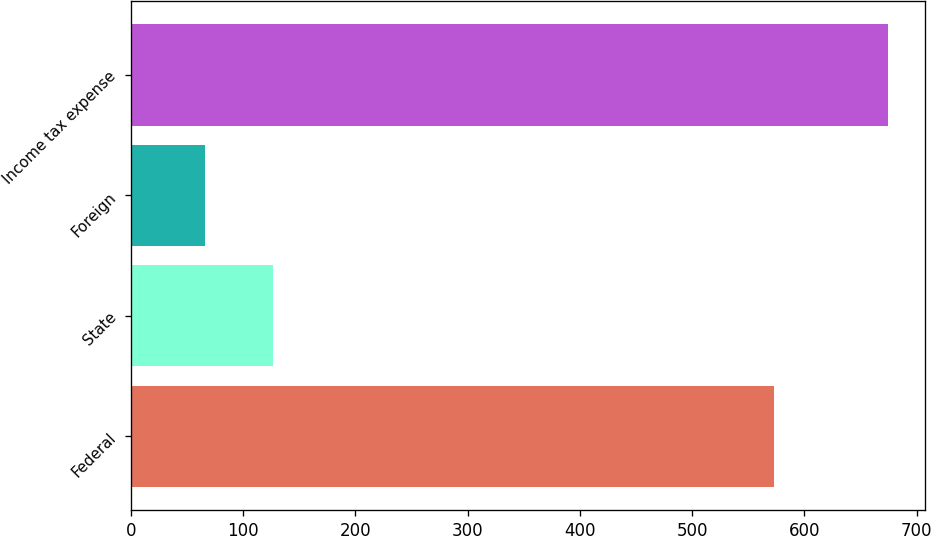<chart> <loc_0><loc_0><loc_500><loc_500><bar_chart><fcel>Federal<fcel>State<fcel>Foreign<fcel>Income tax expense<nl><fcel>573<fcel>126.8<fcel>66<fcel>674<nl></chart> 